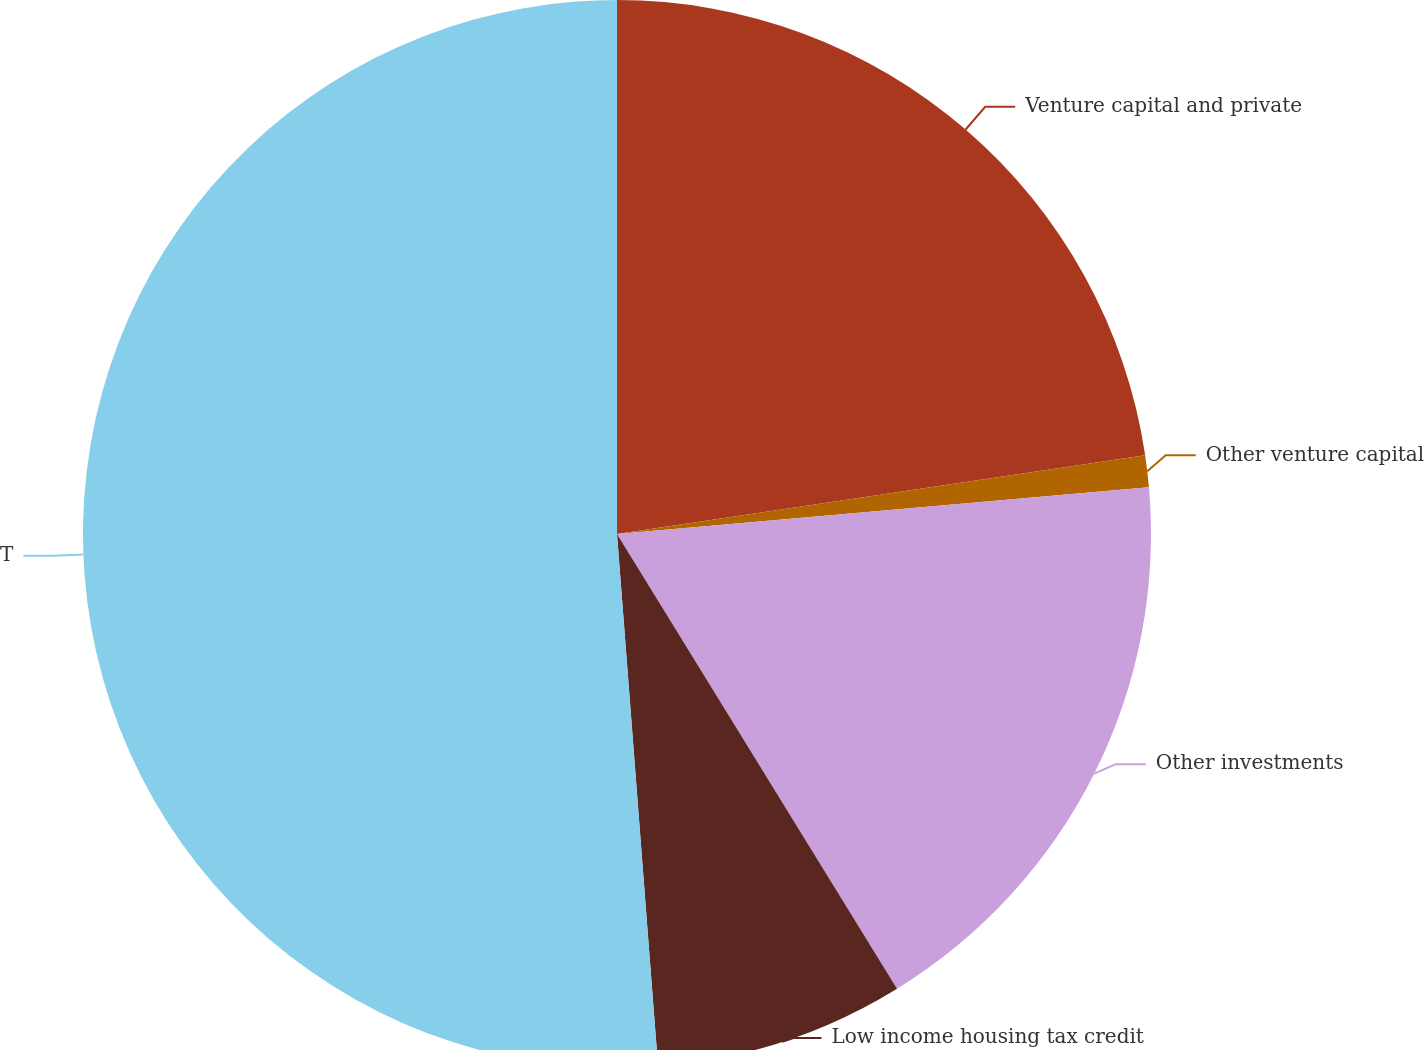<chart> <loc_0><loc_0><loc_500><loc_500><pie_chart><fcel>Venture capital and private<fcel>Other venture capital<fcel>Other investments<fcel>Low income housing tax credit<fcel>Total non-marketable and other<nl><fcel>22.64%<fcel>0.96%<fcel>17.61%<fcel>7.56%<fcel>51.22%<nl></chart> 